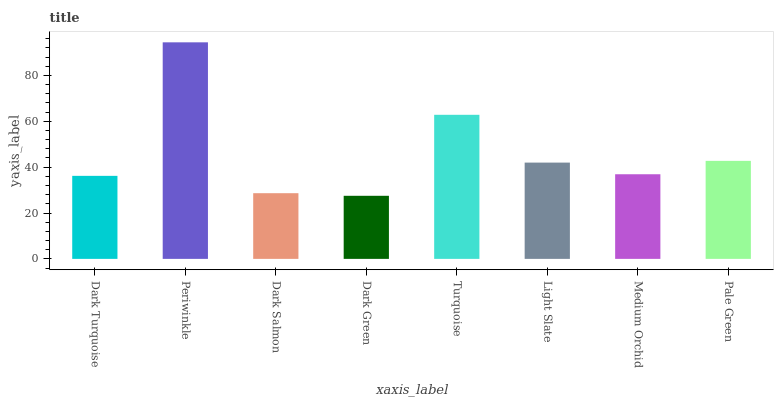Is Dark Green the minimum?
Answer yes or no. Yes. Is Periwinkle the maximum?
Answer yes or no. Yes. Is Dark Salmon the minimum?
Answer yes or no. No. Is Dark Salmon the maximum?
Answer yes or no. No. Is Periwinkle greater than Dark Salmon?
Answer yes or no. Yes. Is Dark Salmon less than Periwinkle?
Answer yes or no. Yes. Is Dark Salmon greater than Periwinkle?
Answer yes or no. No. Is Periwinkle less than Dark Salmon?
Answer yes or no. No. Is Light Slate the high median?
Answer yes or no. Yes. Is Medium Orchid the low median?
Answer yes or no. Yes. Is Dark Green the high median?
Answer yes or no. No. Is Dark Turquoise the low median?
Answer yes or no. No. 